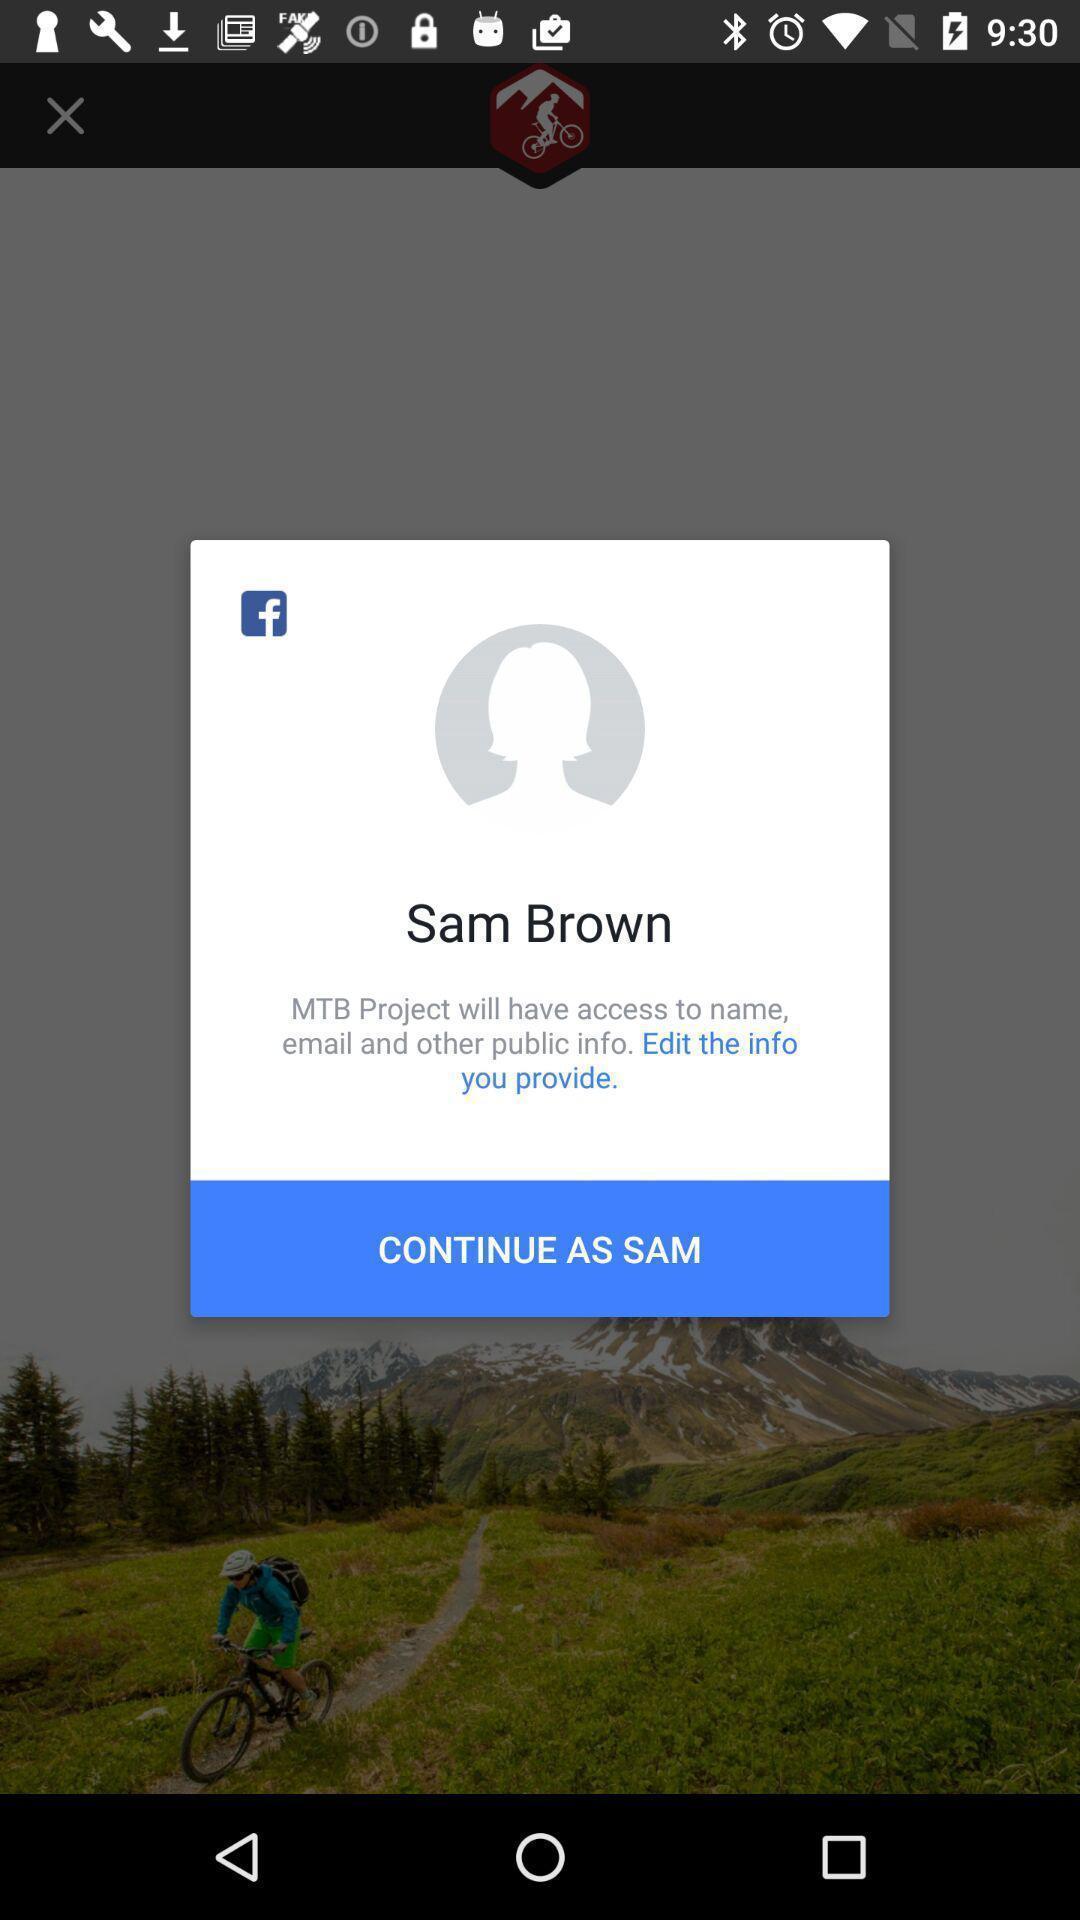Describe the content in this image. Pop-up asking permissions to access the profile details. 